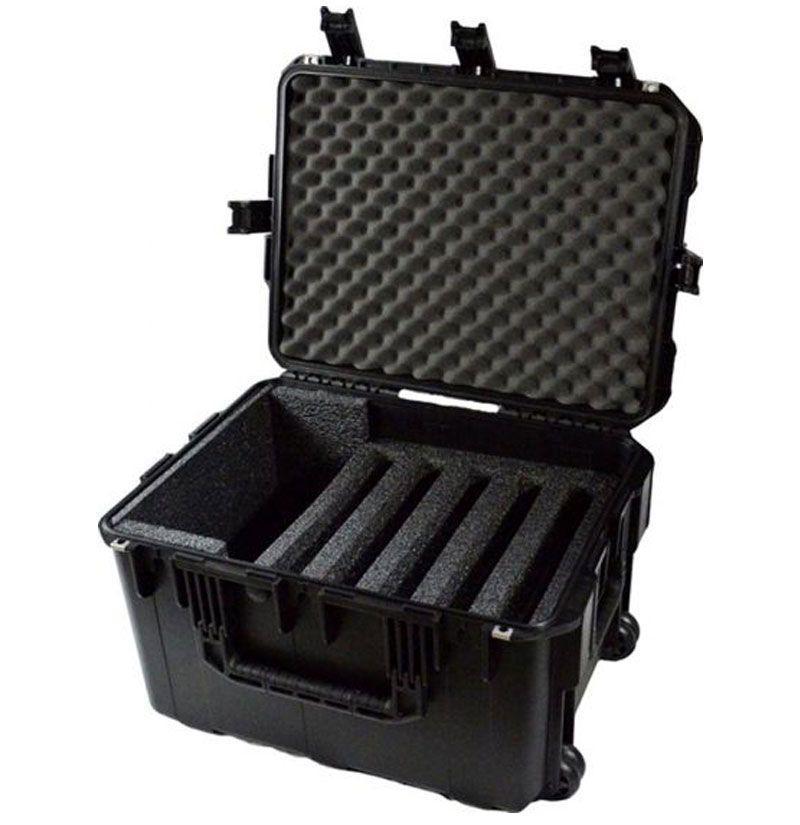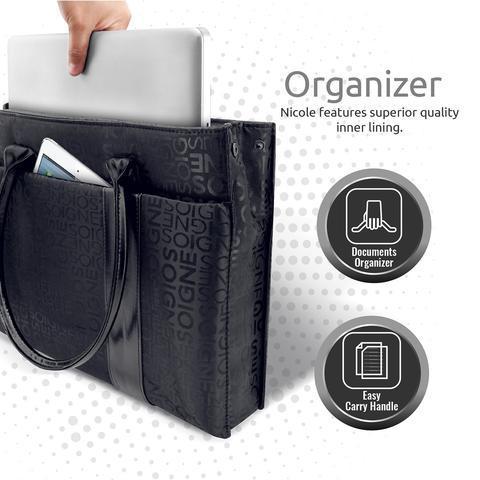The first image is the image on the left, the second image is the image on the right. Considering the images on both sides, is "A carrying case stands upright and closed with another case in one of the images." valid? Answer yes or no. No. The first image is the image on the left, the second image is the image on the right. For the images shown, is this caption "One of the cases shown is closed, standing upright, and has a handle sticking out of the top for pushing or pulling the case." true? Answer yes or no. No. 